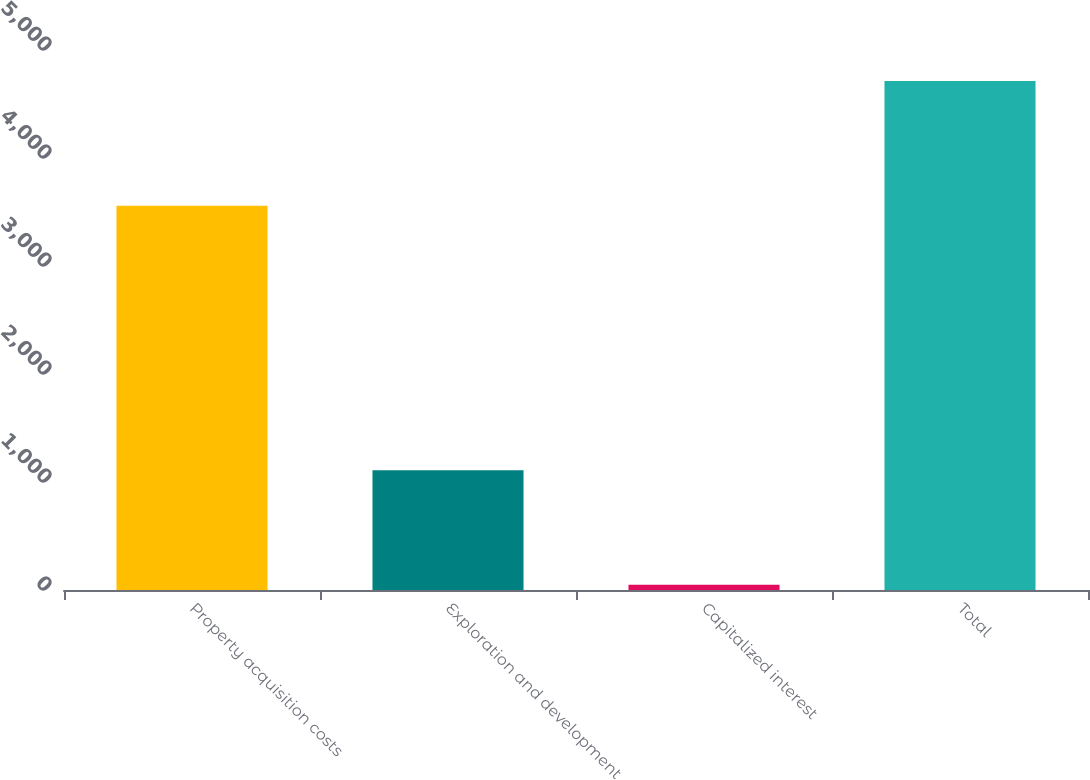Convert chart. <chart><loc_0><loc_0><loc_500><loc_500><bar_chart><fcel>Property acquisition costs<fcel>Exploration and development<fcel>Capitalized interest<fcel>Total<nl><fcel>3558<fcel>1108<fcel>48<fcel>4714<nl></chart> 